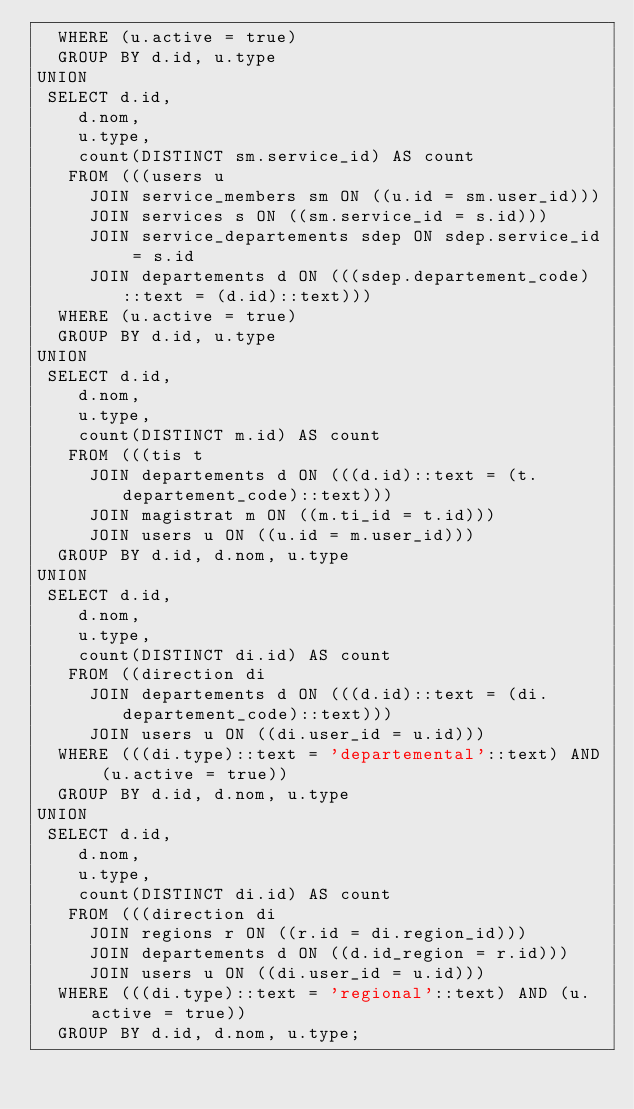Convert code to text. <code><loc_0><loc_0><loc_500><loc_500><_SQL_>  WHERE (u.active = true)
  GROUP BY d.id, u.type
UNION
 SELECT d.id,
    d.nom,
    u.type,
    count(DISTINCT sm.service_id) AS count
   FROM (((users u
     JOIN service_members sm ON ((u.id = sm.user_id)))
     JOIN services s ON ((sm.service_id = s.id)))
     JOIN service_departements sdep ON sdep.service_id = s.id
     JOIN departements d ON (((sdep.departement_code)::text = (d.id)::text)))
  WHERE (u.active = true)
  GROUP BY d.id, u.type
UNION
 SELECT d.id,
    d.nom,
    u.type,
    count(DISTINCT m.id) AS count
   FROM (((tis t
     JOIN departements d ON (((d.id)::text = (t.departement_code)::text)))
     JOIN magistrat m ON ((m.ti_id = t.id)))
     JOIN users u ON ((u.id = m.user_id)))
  GROUP BY d.id, d.nom, u.type
UNION
 SELECT d.id,
    d.nom,
    u.type,
    count(DISTINCT di.id) AS count
   FROM ((direction di
     JOIN departements d ON (((d.id)::text = (di.departement_code)::text)))
     JOIN users u ON ((di.user_id = u.id)))
  WHERE (((di.type)::text = 'departemental'::text) AND (u.active = true))
  GROUP BY d.id, d.nom, u.type
UNION
 SELECT d.id,
    d.nom,
    u.type,
    count(DISTINCT di.id) AS count
   FROM (((direction di
     JOIN regions r ON ((r.id = di.region_id)))
     JOIN departements d ON ((d.id_region = r.id)))
     JOIN users u ON ((di.user_id = u.id)))
  WHERE (((di.type)::text = 'regional'::text) AND (u.active = true))
  GROUP BY d.id, d.nom, u.type;
</code> 